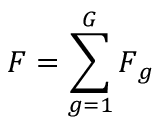<formula> <loc_0><loc_0><loc_500><loc_500>F = \sum _ { g = 1 } ^ { G } F _ { g }</formula> 